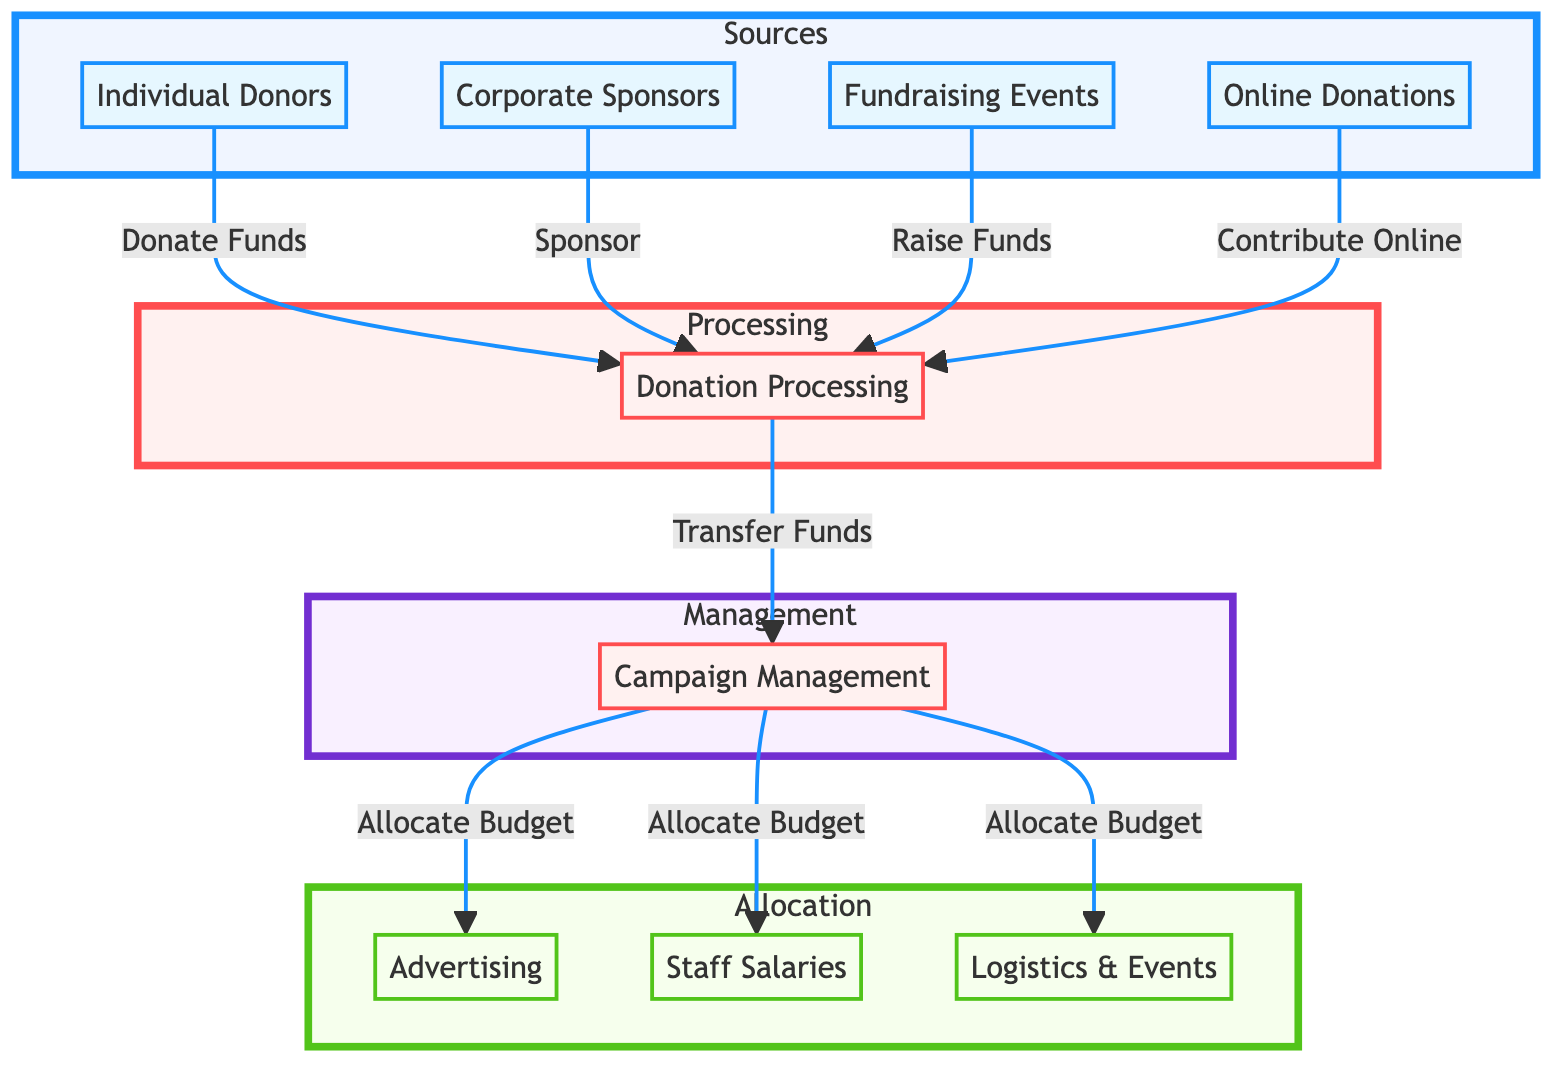What are the sources of campaign donations? The diagram shows four sources of campaign donations: individual donors, corporate sponsors, fundraising events, and online donations.
Answer: individual donors, corporate sponsors, fundraising events, online donations How many nodes are in the Processing section? The diagram contains one node in the Processing section, which is "Donation Processing."
Answer: 1 Which node directly receives donations? The "Donation Processing" node receives donations from all four sources marked by arrows leading into it.
Answer: Donation Processing What does the Campaign Management node do? The "Campaign Management" node allocates the budget to three different activities: advertising, staff salaries, and logistics & events.
Answer: Allocate Budget Which source contributes funds through online means? The source labeled "Online Donations" indicates the specific avenue through which donations are made online.
Answer: Online Donations How many allocation activities are listed? The diagram identifies three allocation activities: advertising, staff salaries, and logistics & events as designated by their nodes.
Answer: 3 What flows from the Donation Processing node to the Campaign Management node? The flow from the Donation Processing node to the Campaign Management node is labeled as "Transfer Funds." This indicates the movement of funds before management decisions are made.
Answer: Transfer Funds What is the relationship between Corporate Sponsors and Donation Processing? Corporate Sponsors are connected to Donation Processing with the label indicating they "Sponsor" contributions, establishing a direct link of financial support.
Answer: Sponsor Which node leads to Advertising? The "Campaign Management" node leads to "Advertising," indicating that budget decisions for advertising come from campaign management.
Answer: Campaign Management 